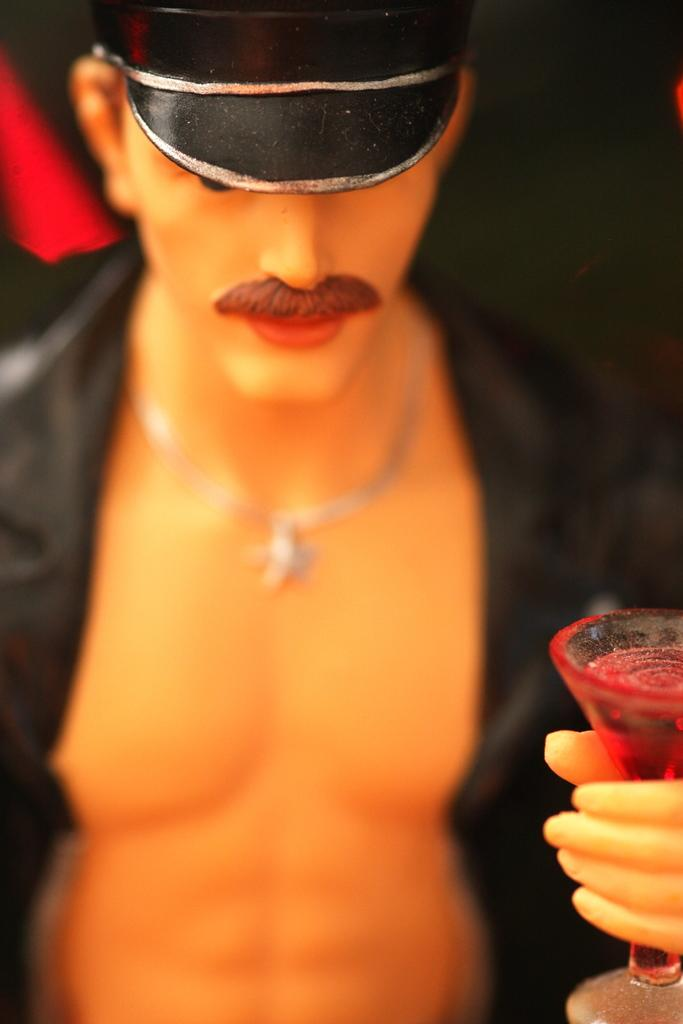What is the main subject of the image? There is a statue in the image. What is the statue holding in its hand? The statue is holding a glass. What accessory is the statue wearing on its head? The statue has a hat on its head. What type of gun is the statue holding in the image? There is no gun present in the image; the statue is holding a glass. What type of cloth is draped over the statue's shoulders in the image? There is no cloth draped over the statue's shoulders in the image; the statue is wearing a hat on its head. 